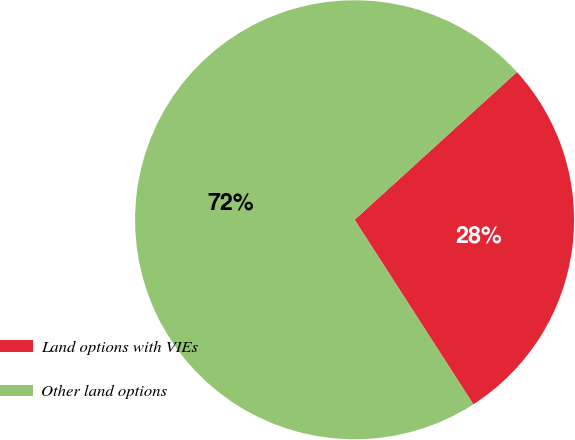Convert chart. <chart><loc_0><loc_0><loc_500><loc_500><pie_chart><fcel>Land options with VIEs<fcel>Other land options<nl><fcel>27.65%<fcel>72.35%<nl></chart> 